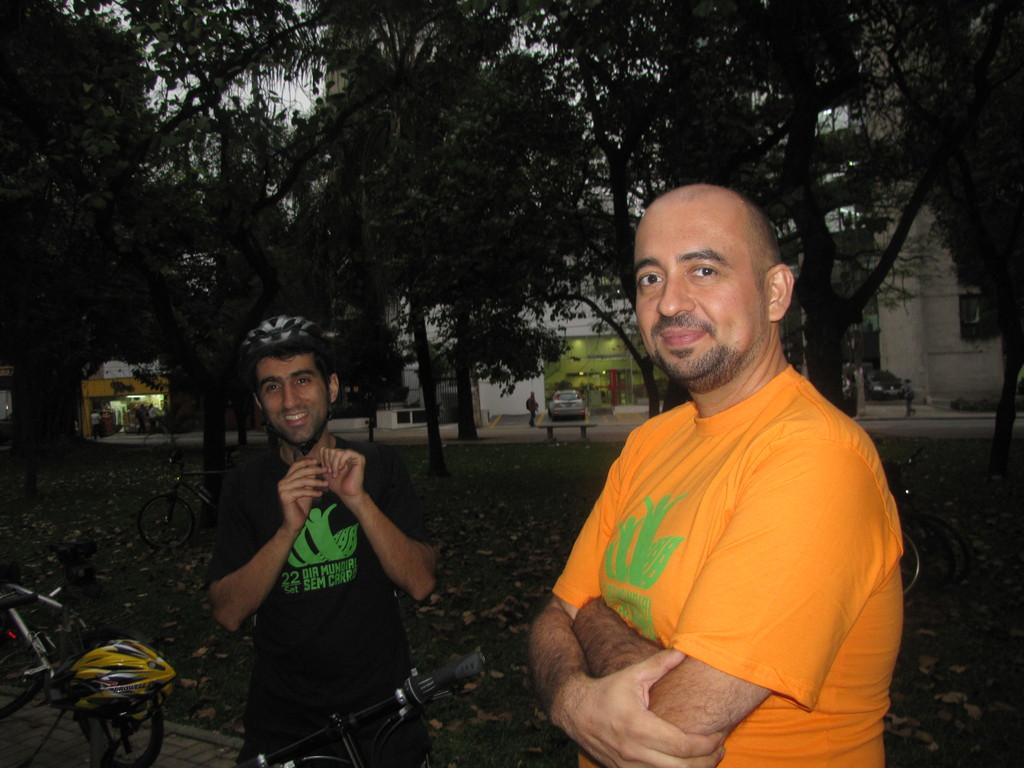How many people are in the image? There are two men in the image. What is one of the men wearing? One of the men is wearing a helmet. What object is beside one of the men? There is a bicycle beside one of the men. What can be seen in the background of the image? There are trees and buildings in the background of the image. What type of sugar is being used to sweeten the jelly in the image? There is no sugar or jelly present in the image. 